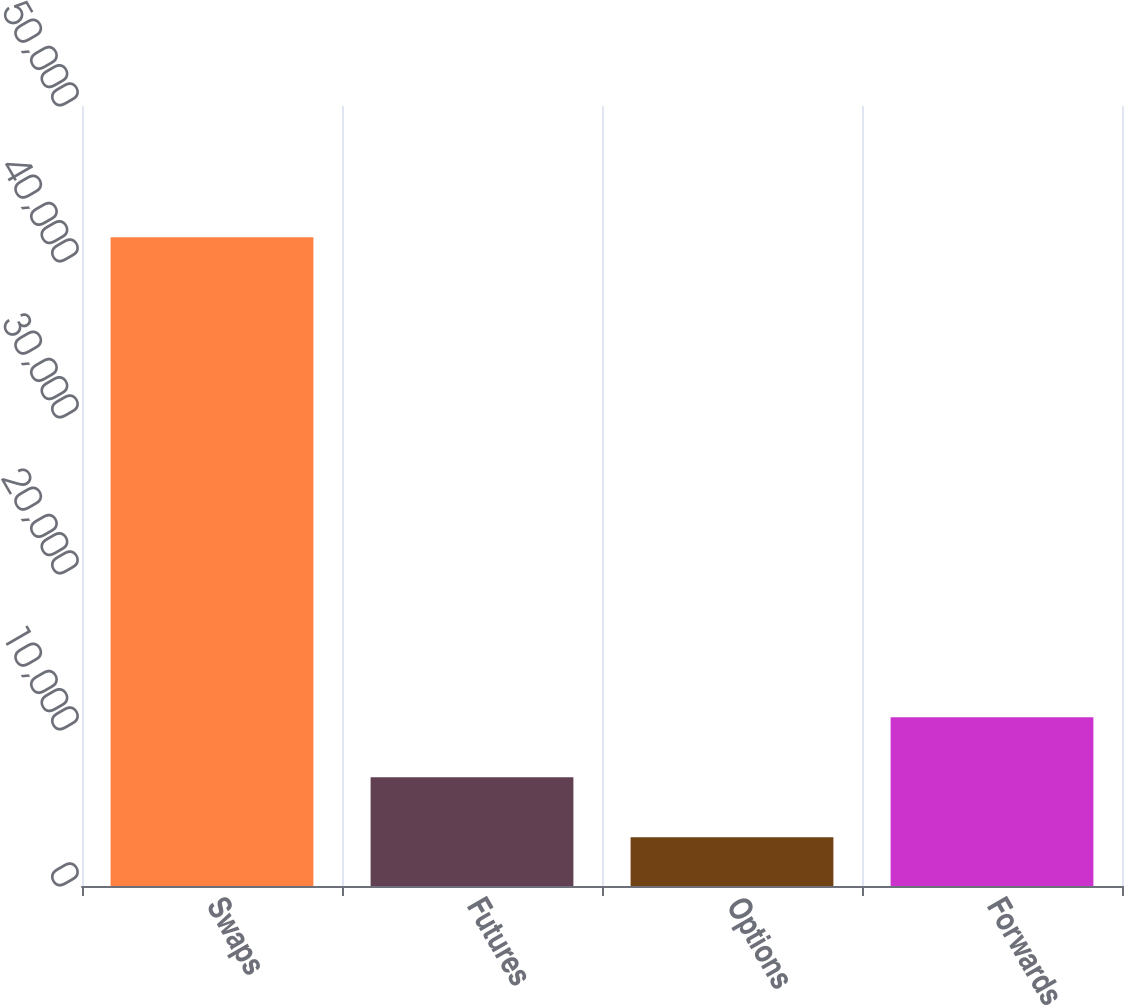Convert chart to OTSL. <chart><loc_0><loc_0><loc_500><loc_500><bar_chart><fcel>Swaps<fcel>Futures<fcel>Options<fcel>Forwards<nl><fcel>41582<fcel>6976.1<fcel>3131<fcel>10821.2<nl></chart> 